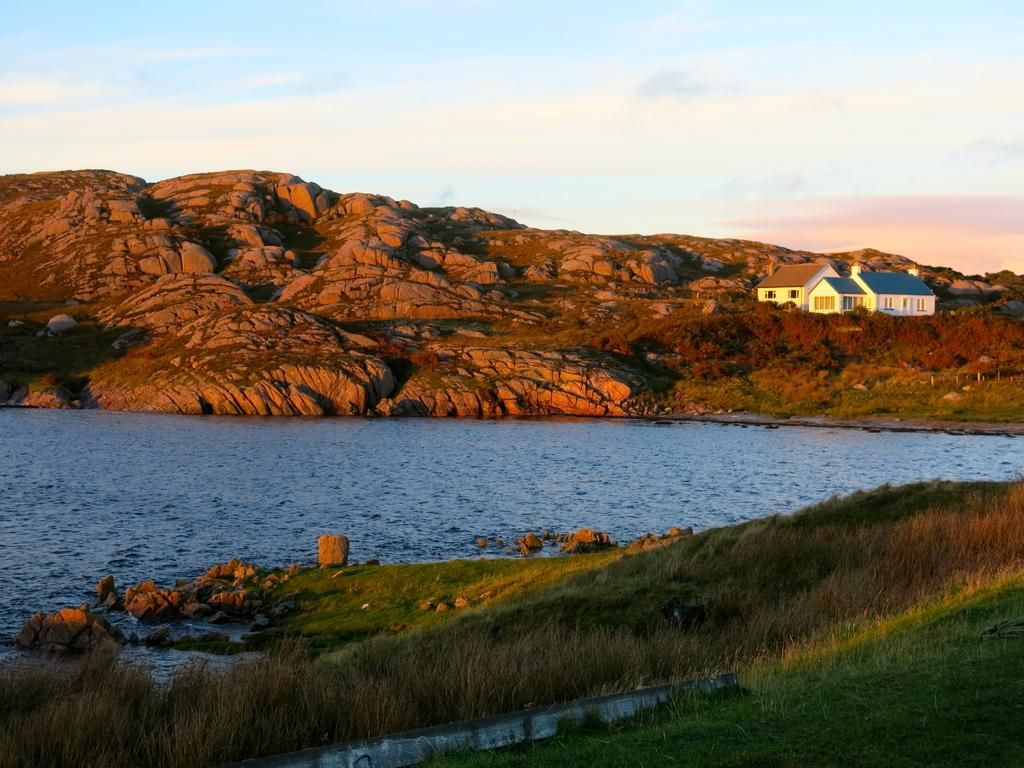What type of terrain is shown in the image? There are houses on a mountain in the image, which suggests a hilly or mountainous terrain. What type of vegetation can be seen in the image? There is grass visible in the image. What natural feature can be seen in the image? There is water visible in the image. What is visible in the background of the image? The sky is visible in the image. How does the statement affect the friction between the bikes in the image? There are no bikes present in the image, so the statement does not affect any friction between them. 